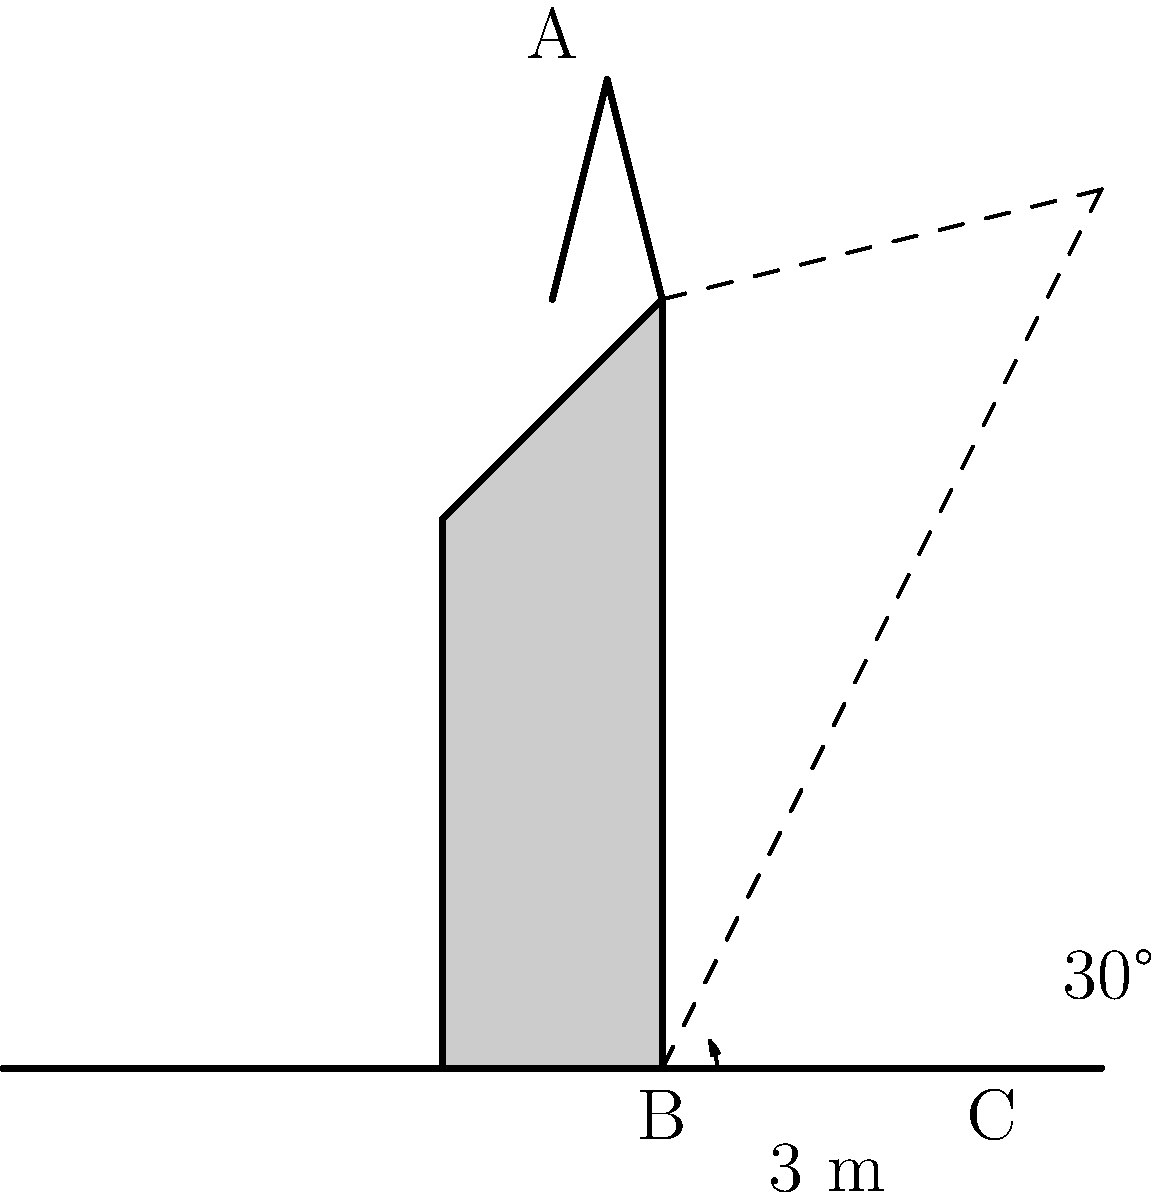Father Mbiku is teaching a lesson on the importance of geometric principles in church architecture. He uses the local church as an example, focusing on its steeple. The shadow of the steeple extends 3 meters from the base of the church when the angle of elevation of the sun is 30°. Using this information, estimate the height of the steeple. Round your answer to the nearest tenth of a meter. Let's approach this step-by-step using trigonometry:

1) In the diagram, we have a right triangle formed by:
   - The steeple (AB)
   - The shadow (BC)
   - The sun's ray (AC)

2) We know:
   - The length of the shadow (BC) = 3 meters
   - The angle of elevation of the sun = 30°

3) In this right triangle, we need to find the opposite side (AB) given the adjacent side (BC) and the angle.

4) This scenario calls for the tangent function:

   $\tan \theta = \frac{\text{opposite}}{\text{adjacent}}$

5) Substituting our known values:

   $\tan 30° = \frac{\text{height of steeple}}{3}$

6) We can rearrange this to solve for the height:

   $\text{height of steeple} = 3 \times \tan 30°$

7) Now, let's calculate:
   $\tan 30° \approx 0.577350269$

   $\text{height of steeple} = 3 \times 0.577350269 \approx 1.732050808$ meters

8) Rounding to the nearest tenth:

   $\text{height of steeple} \approx 1.7$ meters

Therefore, the estimated height of the steeple is approximately 1.7 meters.
Answer: 1.7 meters 